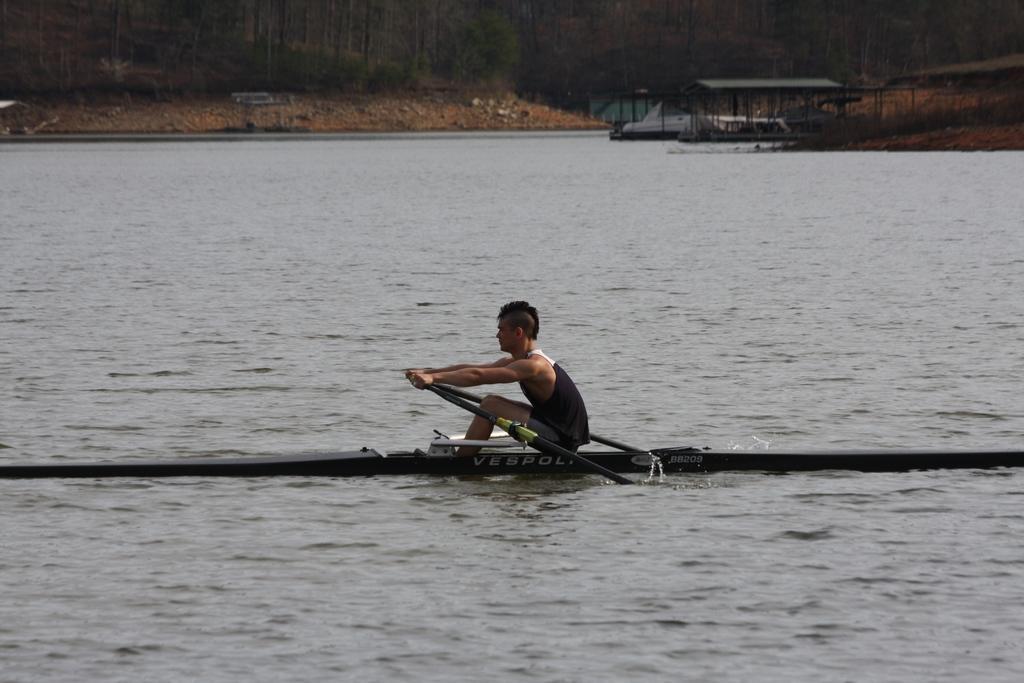In one or two sentences, can you explain what this image depicts? This picture describe about a man wearing a black color sleeveless shirt riding a small boat in the water. Behind we can see two more boat standing in the water. In the background we can see some trees. 